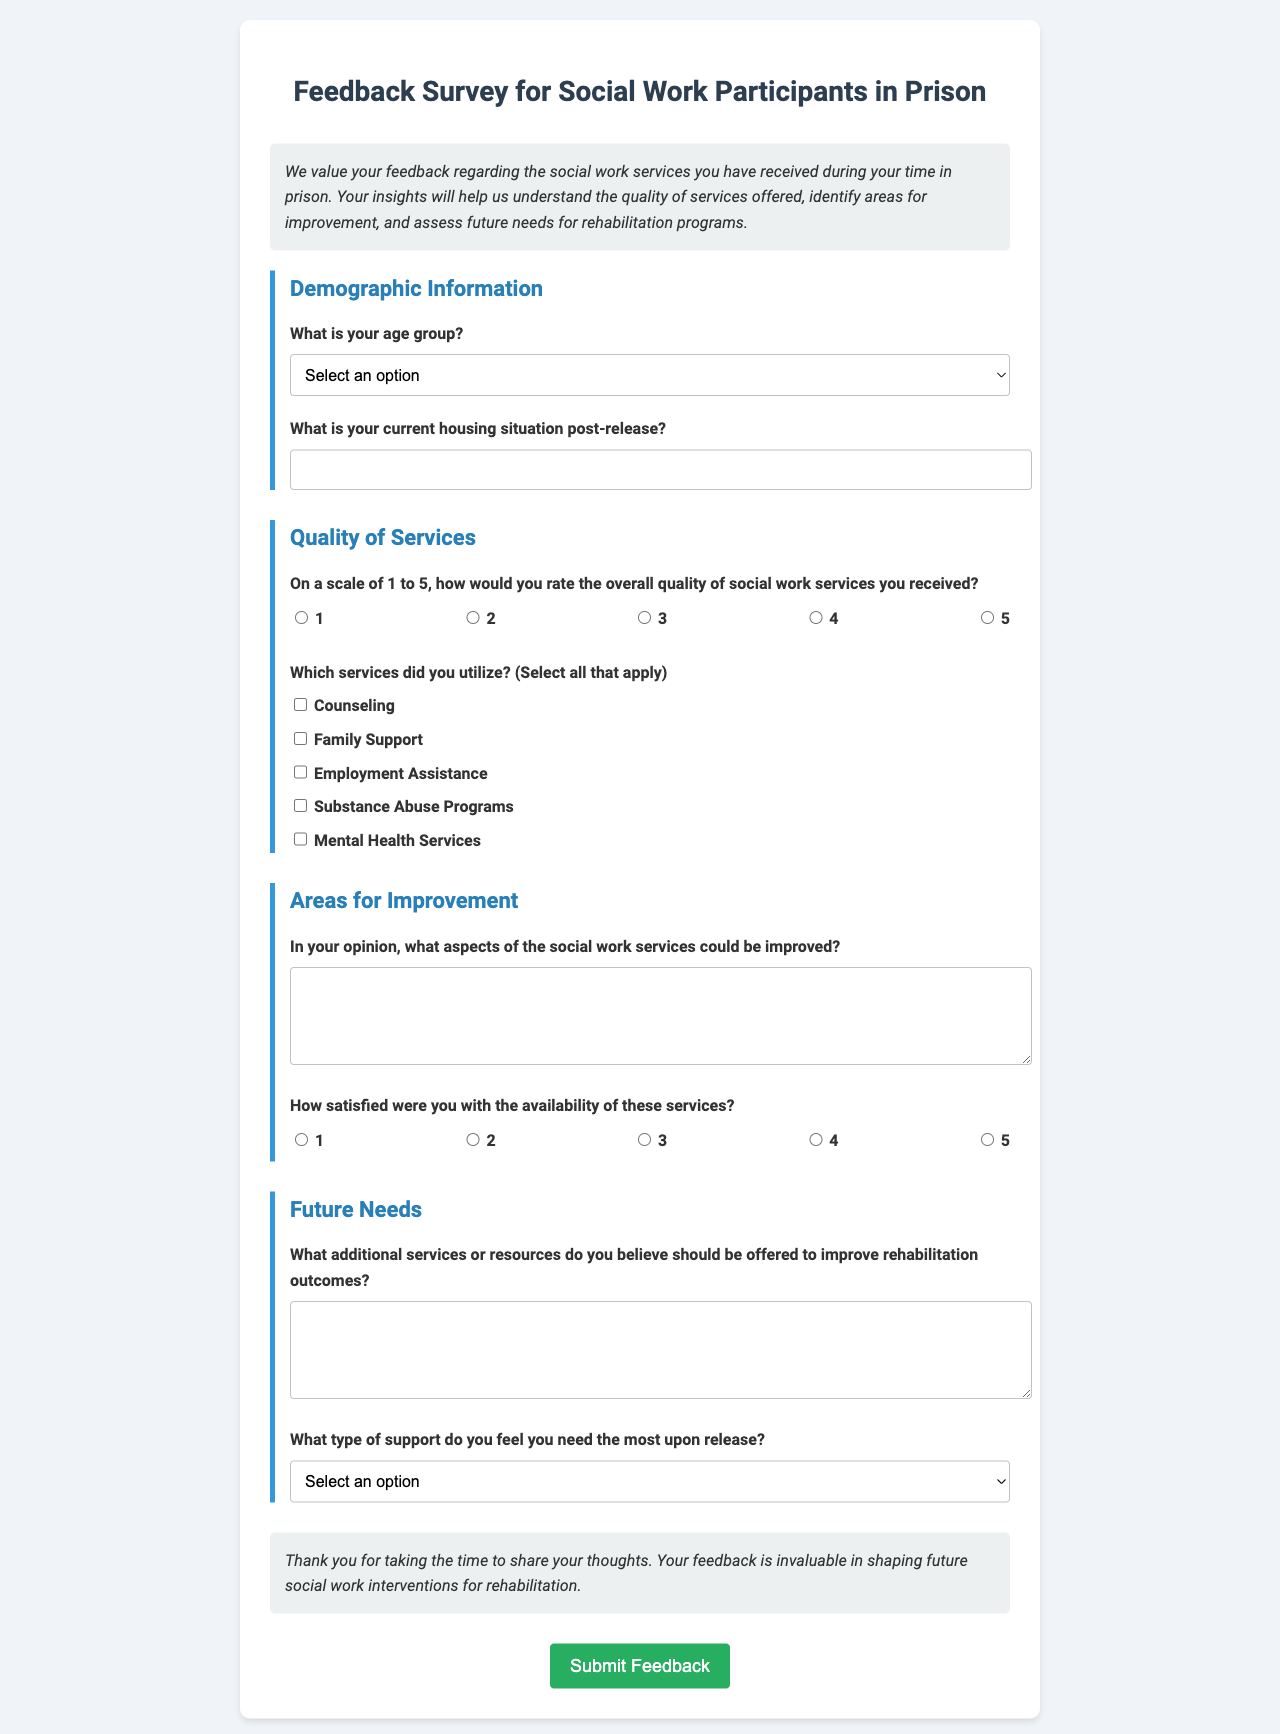What is the title of the document? The title is clearly stated at the top of the document indicating the purpose of the survey.
Answer: Feedback Survey for Social Work Participants in Prison What age group is the first selection option for respondents? The first option in the age group selection is listed in the dropdown menu provided in the demographic information section.
Answer: 18-25 What type of support is the last option in the support type selection? The options listed in the support type section include choices for the type of support respondents might need upon release.
Answer: Continuing Education How many services can participants select in the quality of services section? The document allows participants to select multiple services, as indicated in the quality of services section that has a checkbox format.
Answer: Unlimited What rating scale is used to assess overall service quality? The document indicates a scale used for rating, allowing participants to evaluate the quality of services received.
Answer: 1 to 5 What is one area mentioned that participants can suggest for improvement? The document provides an open-ended question for participants to express their views on improvement areas.
Answer: Aspects of social work services How many questions are included in the 'Future Needs' section? The future needs section has two questions addressing needs for additional services and types of support.
Answer: 2 What color is the background of the document? The document design features a specific background color that enhances readability and presentation.
Answer: Light gray What type of document is this? The purpose and format of the document indicate it is a feedback collection tool aimed at specific participants.
Answer: Survey 